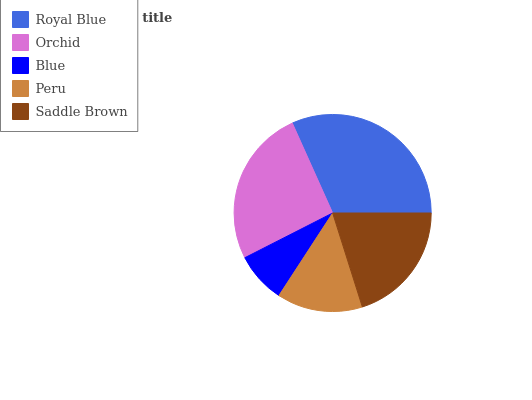Is Blue the minimum?
Answer yes or no. Yes. Is Royal Blue the maximum?
Answer yes or no. Yes. Is Orchid the minimum?
Answer yes or no. No. Is Orchid the maximum?
Answer yes or no. No. Is Royal Blue greater than Orchid?
Answer yes or no. Yes. Is Orchid less than Royal Blue?
Answer yes or no. Yes. Is Orchid greater than Royal Blue?
Answer yes or no. No. Is Royal Blue less than Orchid?
Answer yes or no. No. Is Saddle Brown the high median?
Answer yes or no. Yes. Is Saddle Brown the low median?
Answer yes or no. Yes. Is Orchid the high median?
Answer yes or no. No. Is Blue the low median?
Answer yes or no. No. 